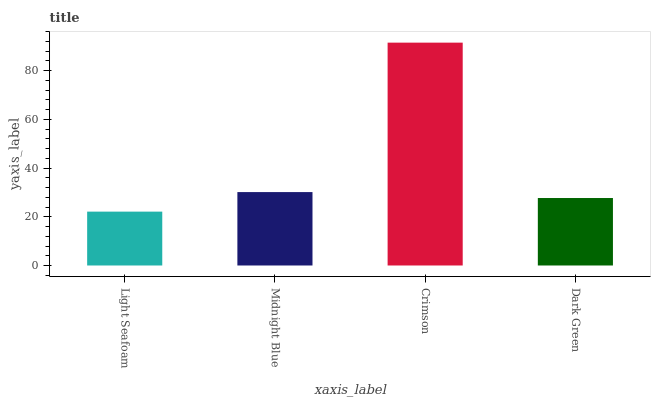Is Light Seafoam the minimum?
Answer yes or no. Yes. Is Crimson the maximum?
Answer yes or no. Yes. Is Midnight Blue the minimum?
Answer yes or no. No. Is Midnight Blue the maximum?
Answer yes or no. No. Is Midnight Blue greater than Light Seafoam?
Answer yes or no. Yes. Is Light Seafoam less than Midnight Blue?
Answer yes or no. Yes. Is Light Seafoam greater than Midnight Blue?
Answer yes or no. No. Is Midnight Blue less than Light Seafoam?
Answer yes or no. No. Is Midnight Blue the high median?
Answer yes or no. Yes. Is Dark Green the low median?
Answer yes or no. Yes. Is Light Seafoam the high median?
Answer yes or no. No. Is Midnight Blue the low median?
Answer yes or no. No. 